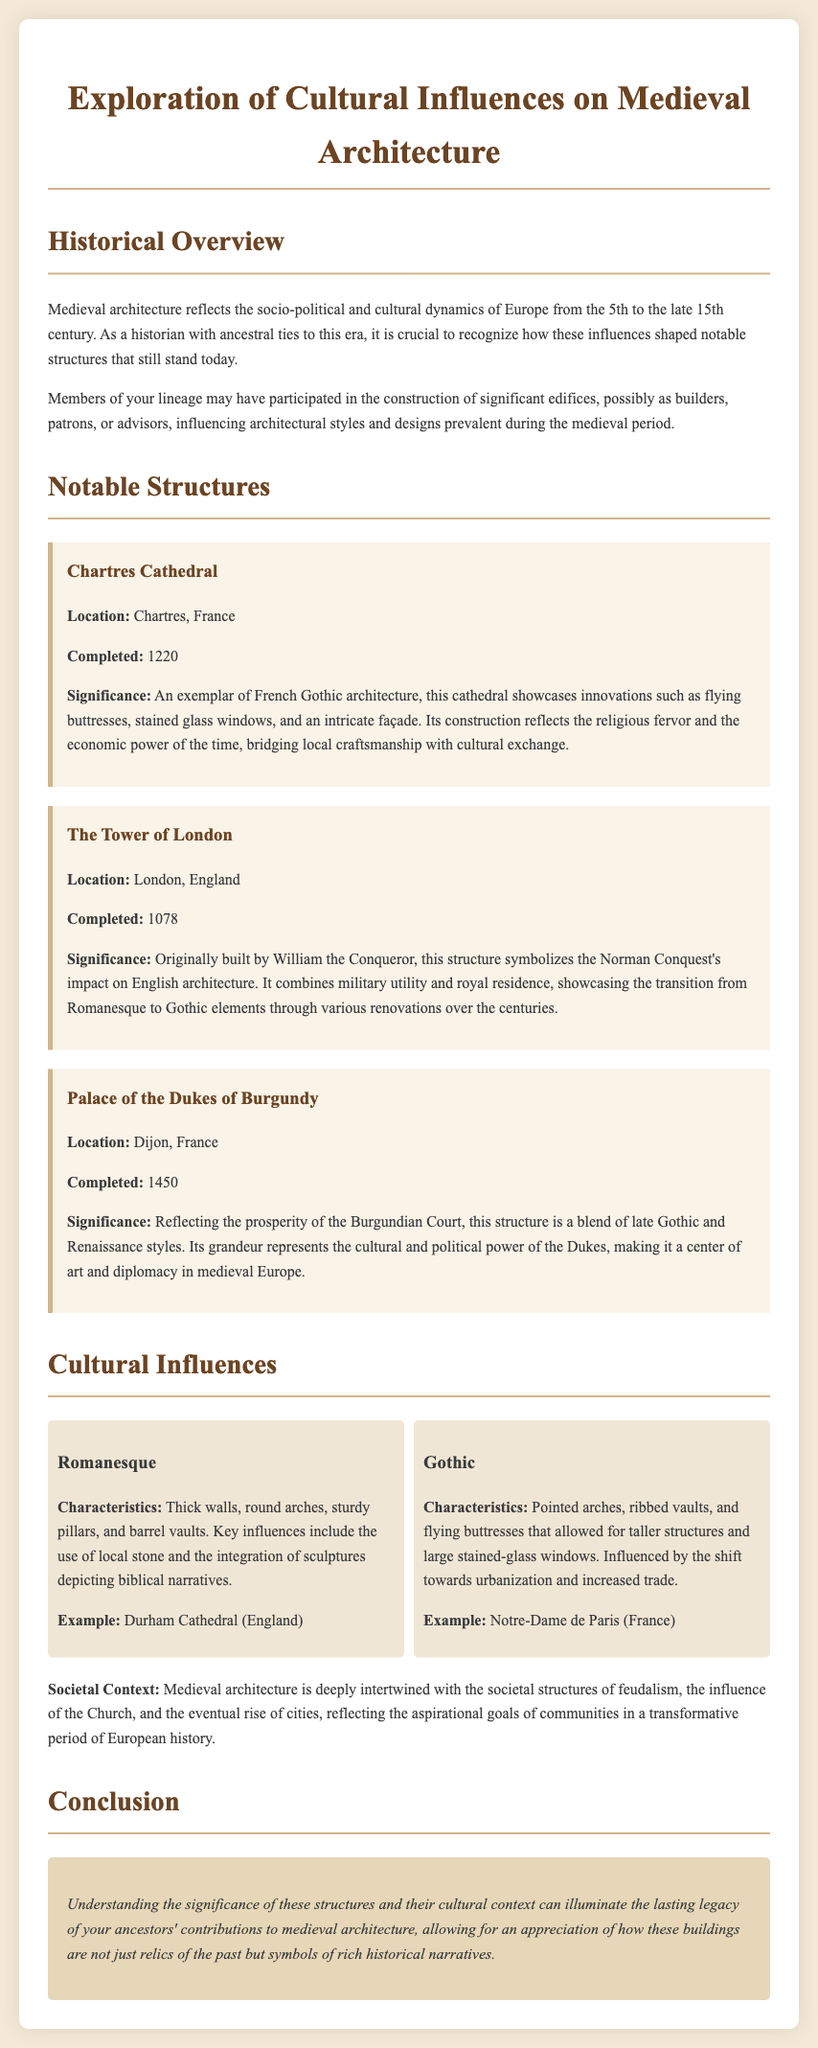what is the title of the document? The title of the document is presented at the top of the memo.
Answer: Exploration of Cultural Influences on Medieval Architecture where is Chartres Cathedral located? The location of Chartres Cathedral is listed in the notable structures section.
Answer: Chartres, France what architectural style is featured in the Tower of London? The architectural style of the Tower of London is mentioned in relation to its construction.
Answer: Norman Conquest when was the Palace of the Dukes of Burgundy completed? The completion year is specified in the notable structures section of the document.
Answer: 1450 what are two characteristics of Gothic architecture? The characteristics of Gothic architecture are described in the cultural influences section.
Answer: Pointed arches, flying buttresses how did medieval architecture reflect societal structures? The document discusses the connection between architecture and societal structures in the context of feudalism and the Church.
Answer: Deeply intertwined with feudalism and the Church which cathedral is an example of Romanesque architecture? An example of Romanesque architecture is provided in the cultural influences section.
Answer: Durham Cathedral what year was Chartres Cathedral completed? The completion year is explicitly mentioned in the notable structures section.
Answer: 1220 what does the conclusion emphasize about ancestors' contributions? The conclusion discusses the significance of contributions to architecture and historical narratives.
Answer: Lasting legacy 